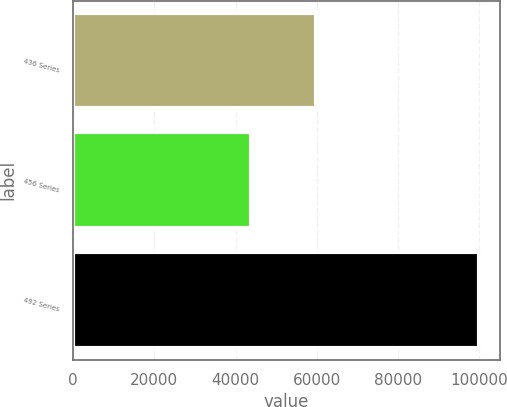Convert chart. <chart><loc_0><loc_0><loc_500><loc_500><bar_chart><fcel>436 Series<fcel>456 Series<fcel>492 Series<nl><fcel>59920<fcel>43887<fcel>100000<nl></chart> 